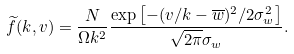<formula> <loc_0><loc_0><loc_500><loc_500>\widetilde { f } ( k , v ) = \frac { N } { \Omega k ^ { 2 } } \frac { \exp \left [ - ( v / k - \overline { w } ) ^ { 2 } / 2 \sigma _ { w } ^ { 2 } \right ] } { \sqrt { 2 \pi } \sigma _ { w } } .</formula> 